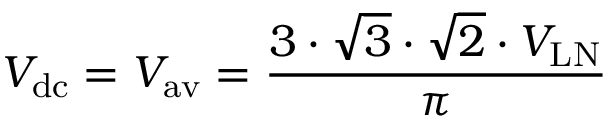Convert formula to latex. <formula><loc_0><loc_0><loc_500><loc_500>V _ { d c } = V _ { a v } = { \frac { 3 \cdot { \sqrt { 3 } } \cdot { \sqrt { 2 } } \cdot V _ { L N } } { \pi } }</formula> 